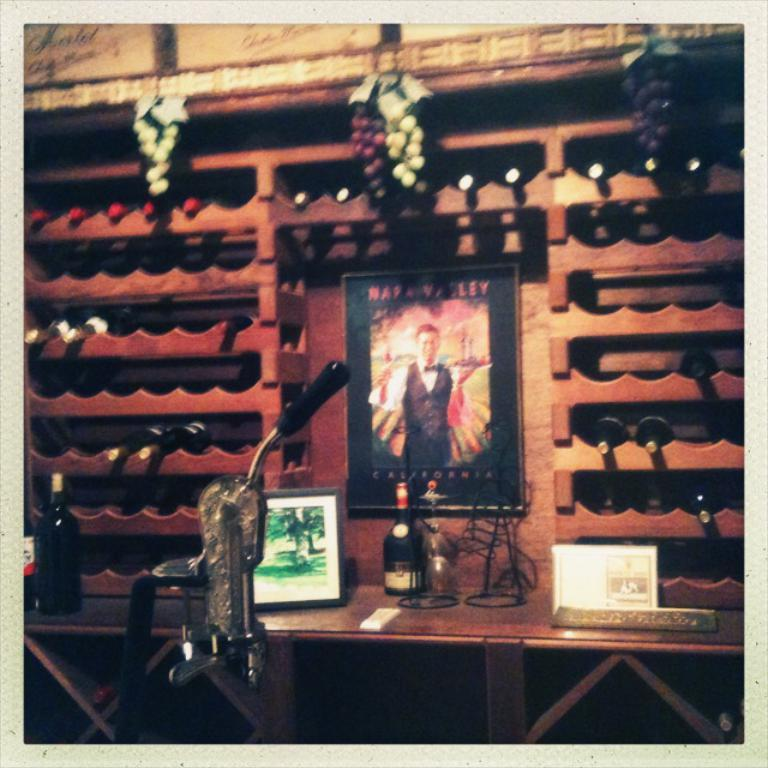Provide a one-sentence caption for the provided image. A poster with a man on it that says California at the bottom. 